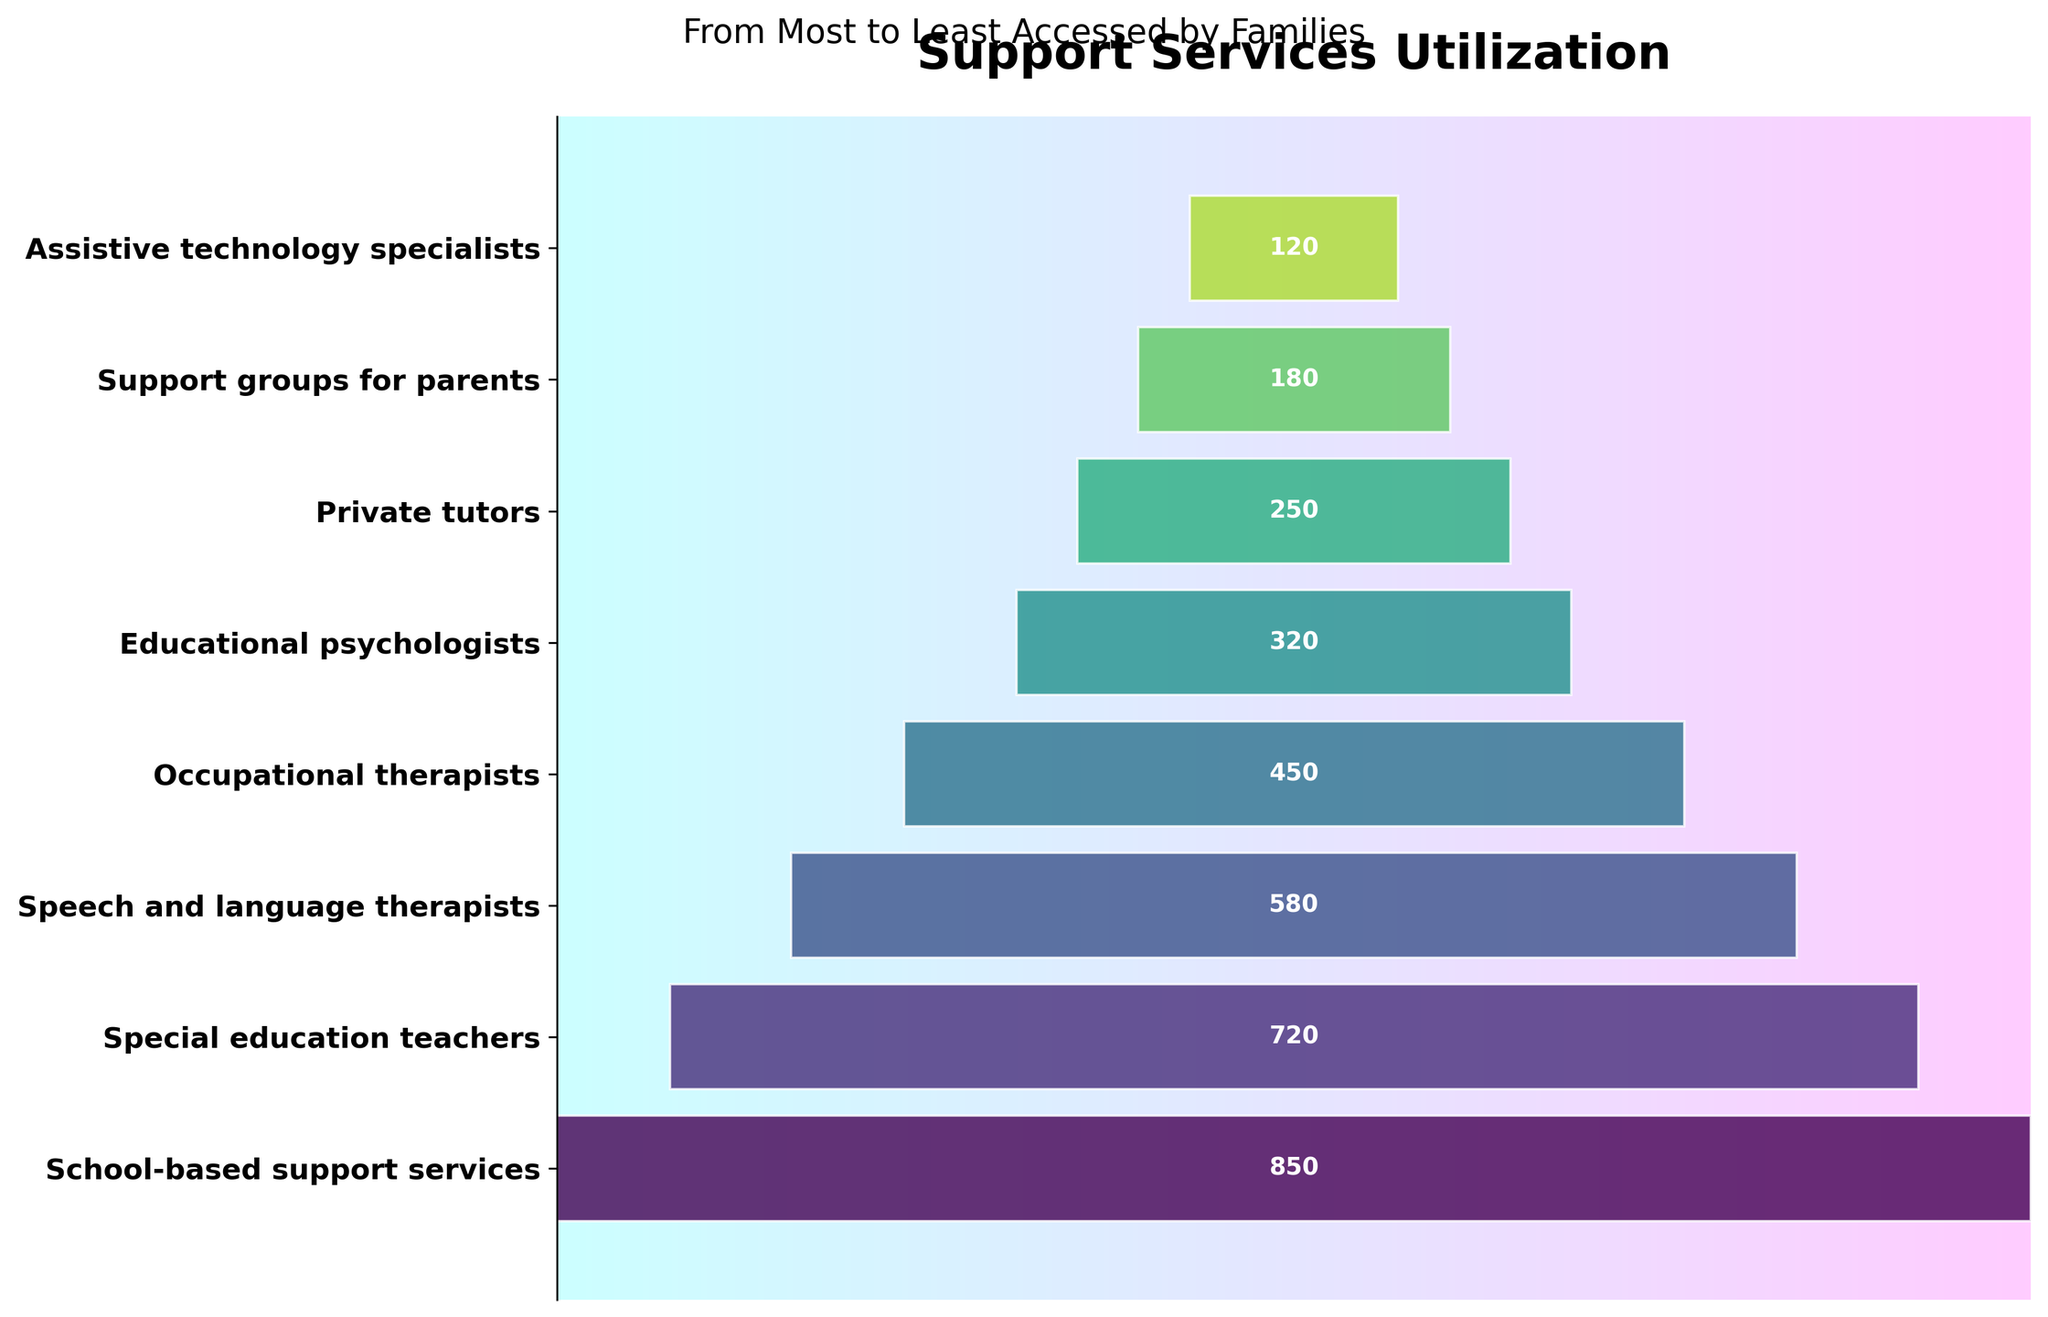What is the title of the figure? The title is usually displayed at the top of the figure. In this case, the title reads "Support Services Utilization."
Answer: Support Services Utilization Which support service is accessed by the most families? The funnel chart displays services from most to least accessed, with the top segment indicating the most accessed service. The topmost service is "School-based support services."
Answer: School-based support services How many families accessed private tutors? Reading the label next to "Private tutors" on the funnel chart, we see that it mentions "250" families.
Answer: 250 Which service is accessed by the fewest number of families? The bottom segment of the funnel represents the service accessed by the fewest families. This is "Assistive technology specialists."
Answer: Assistive technology specialists How many more families access speech and language therapists compared to educational psychologists? The number of families accessing speech and language therapists is 580, and for educational psychologists, it is 320. The difference can be calculated as 580 - 320 = 260.
Answer: 260 What is the total number of families accessing the top three services? The top three services are "School-based support services" (850), "Special education teachers" (720), and "Speech and language therapists" (580). The total is 850 + 720 + 580 = 2150.
Answer: 2150 What proportion of families that access school-based support services also access special education teachers? The number of families accessing school-based support services is 850, and those accessing special education teachers is 720. The proportion is 720 / 850 ≈ 0.847.
Answer: 0.847 Are more families accessing support groups for parents or private tutors? Comparing the labels, 180 families access support groups for parents, while 250 access private tutors. 250 is greater than 180.
Answer: Private tutors If we sum the number of families accessing occupational therapists and special education teachers, what would be the result? Occupational therapists are accessed by 450 families, while special education teachers are accessed by 720. Summing these gives 450 + 720 = 1170.
Answer: 1170 What is the median number of families accessing the services listed? The numbers of families are 850, 720, 580, 450, 320, 250, 180, and 120. When sorted: 120, 180, 250, 320, 450, 580, 720, 850. The middle values are 320 and 450. Their average is (320 + 450) / 2 = 385.
Answer: 385 